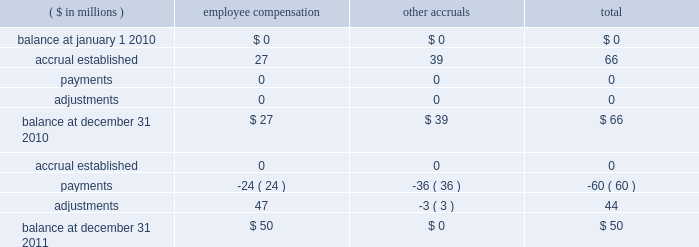Hii expects to incur higher costs to complete ships currently under construction in avondale due to anticipated reductions in productivity .
As a result , in the second quarter of 2010 , the company increased the estimates to complete lpd-23 and lpd-25 by approximately $ 210 million .
The company recognized a $ 113 million pre-tax charge to operating income for these contracts in the second quarter of 2010 .
Hii is exploring alternative uses of the avondale facility , including alternative opportunities for the workforce .
In connection with and as a result of the decision to wind down shipbuilding operations at the avondale , louisiana facility , the company began incurring and paying related employee severance and incentive compensation liabilities and expenditures , asset retirement obligation liabilities that became reasonably estimable , and amounts owed for not meeting certain requirements under its cooperative endeavor agreement with the state of louisiana .
The company anticipates that it will incur substantial other restructuring and facilities shutdown related costs , including , but not limited to , severance expense , relocation expense , and asset write-downs related to the avondale facilities .
These costs are expected to be allowable expenses under government accounting standards and thus should be recoverable in future years 2019 overhead costs .
These future costs could approximate $ 271 million , based on management 2019s current estimate .
Such costs should be recoverable under existing flexibly priced contracts or future negotiated contracts in accordance with federal acquisition regulation ( 201cfar 201d ) provisions relating to the treatment of restructuring and shutdown related costs .
The company is currently in discussions with the u.s .
Navy regarding its cost submission to support the recoverability of these costs under the far and applicable contracts , and this submission is subject to review and acceptance by the u.s .
Navy .
The defense contract audit agency ( 201cdcaa 201d ) , a dod agency , prepared an initial audit report on the company 2019s cost proposal for restructuring and shutdown related costs of $ 310 million , which stated that the proposal was not adequately supported for the dcaa to reach a conclusion and questioned approximately $ 25 million , or 8% ( 8 % ) , of the costs submitted by the company .
Accordingly , the dcaa did not accept the proposal as submitted .
The company has submitted a revised proposal to address the concerns of the dcaa and to reflect a revised estimated total cost of $ 271 million .
Should the company 2019s revised proposal be challenged by the u.s .
Navy , the company would likely pursue prescribed dispute resolution alternatives to resolve the challenge .
That process , however , would create uncertainty as to the timing and eventual allowability of the costs related to the wind down of the avondale facility .
Ultimately , the company anticipates these discussions with the u.s .
Navy will result in an agreement that is substantially in accordance with management 2019s cost recovery expectations .
Accordingly , hii has treated these costs as allowable costs in determining the earnings performance on its contracts in process .
The actual restructuring expenses related to the wind down may be greater than the company 2019s current estimate , and any inability to recover such costs could result in a material effect on the company 2019s consolidated financial position , results of operations or cash flows .
The company also evaluated the effect that the wind down of the avondale facilities might have on the benefit plans in which hii employees participate .
Hii determined that the potential impact of a curtailment in these plans was not material to its consolidated financial position , results of operations or cash flows .
The table below summarizes the company 2019s liability for restructuring and shutdown related costs associated with winding down the avondale facility .
As of december 31 , 2011 and 2010 , these costs are comprised primarily of employee severance and retention and incentive bonuses .
These amounts were capitalized in inventoried costs , and will be recognized as expenses in cost of product sales beginning in 2014 .
( $ in millions ) employee compensation other accruals total .

What was the net adjustments as recorded in 2011 in millions? 
Rationale: the net adjustment is the sum of both activities in 2011
Computations: ((24 * const_m1) + 47)
Answer: 23.0. 